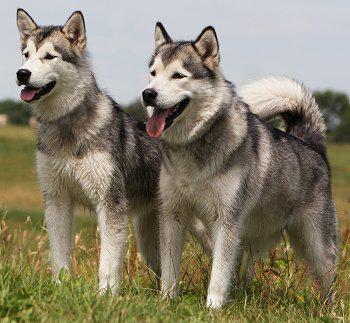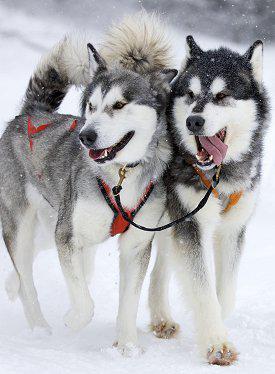The first image is the image on the left, the second image is the image on the right. For the images displayed, is the sentence "There are only two dogs, and both of them are showing their tongues." factually correct? Answer yes or no. No. The first image is the image on the left, the second image is the image on the right. Analyze the images presented: Is the assertion "All dogs are standing, and each image contains a dog with an upturned, curled tail." valid? Answer yes or no. Yes. 